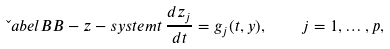<formula> <loc_0><loc_0><loc_500><loc_500>\L a b e l { B B - z - s y s t e m } t \, \frac { d z _ { j } } { d t } = g _ { j } ( t , y ) , \quad j = 1 , \dots , p ,</formula> 